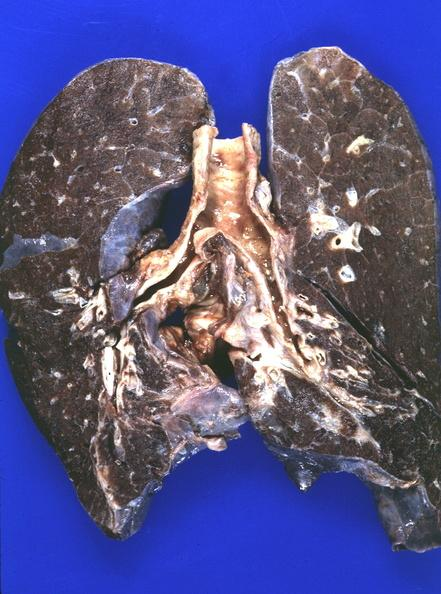does this image show lung, iron overload?
Answer the question using a single word or phrase. Yes 